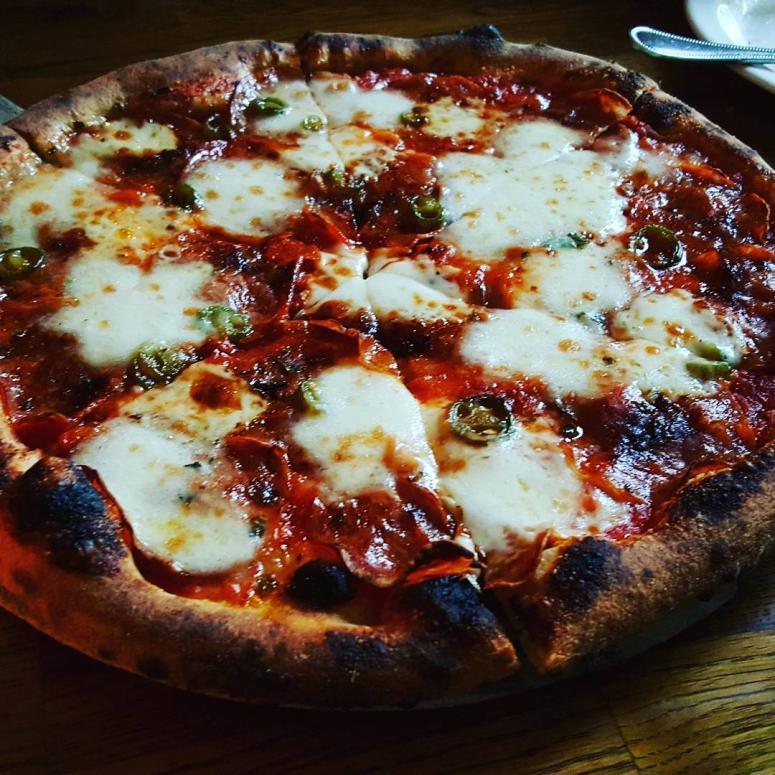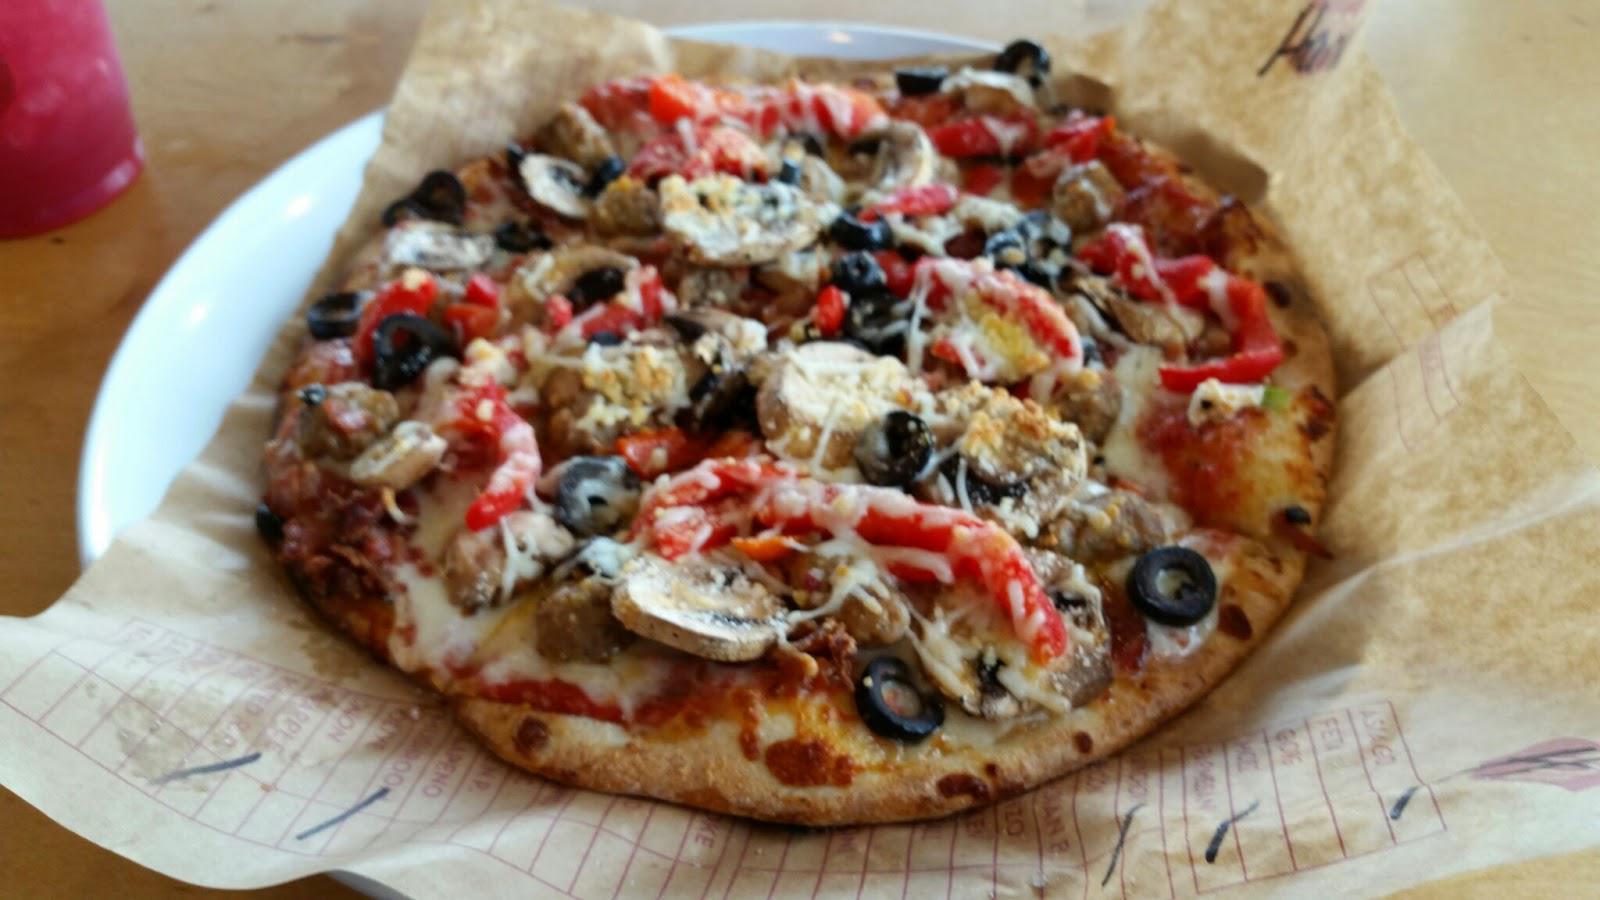The first image is the image on the left, the second image is the image on the right. For the images shown, is this caption "The right image includes a filled glass of amber beer with foam on top, behind a round pizza with a thin crust." true? Answer yes or no. No. The first image is the image on the left, the second image is the image on the right. Assess this claim about the two images: "In the image on the right, there is at least one full mug of beer sitting on the table to the right of the pizza.". Correct or not? Answer yes or no. No. 